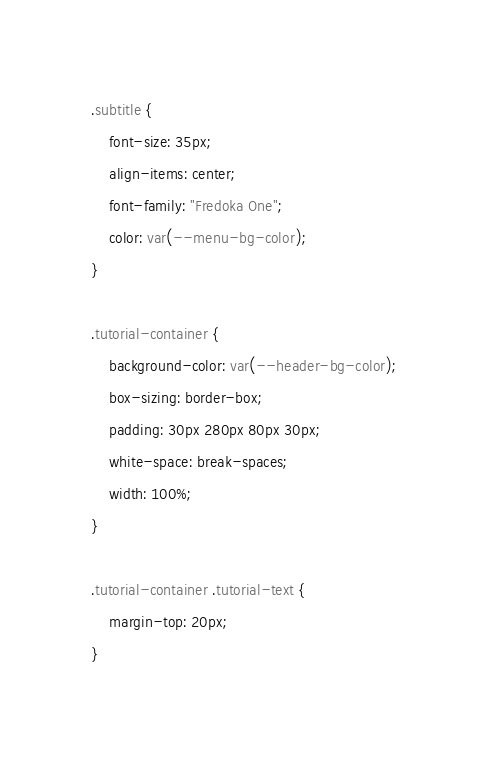<code> <loc_0><loc_0><loc_500><loc_500><_CSS_>.subtitle {
    font-size: 35px;
    align-items: center;
    font-family: "Fredoka One";
    color: var(--menu-bg-color);
}

.tutorial-container {
    background-color: var(--header-bg-color);
    box-sizing: border-box;
    padding: 30px 280px 80px 30px;
    white-space: break-spaces;
    width: 100%;
}

.tutorial-container .tutorial-text {
    margin-top: 20px;
}
</code> 